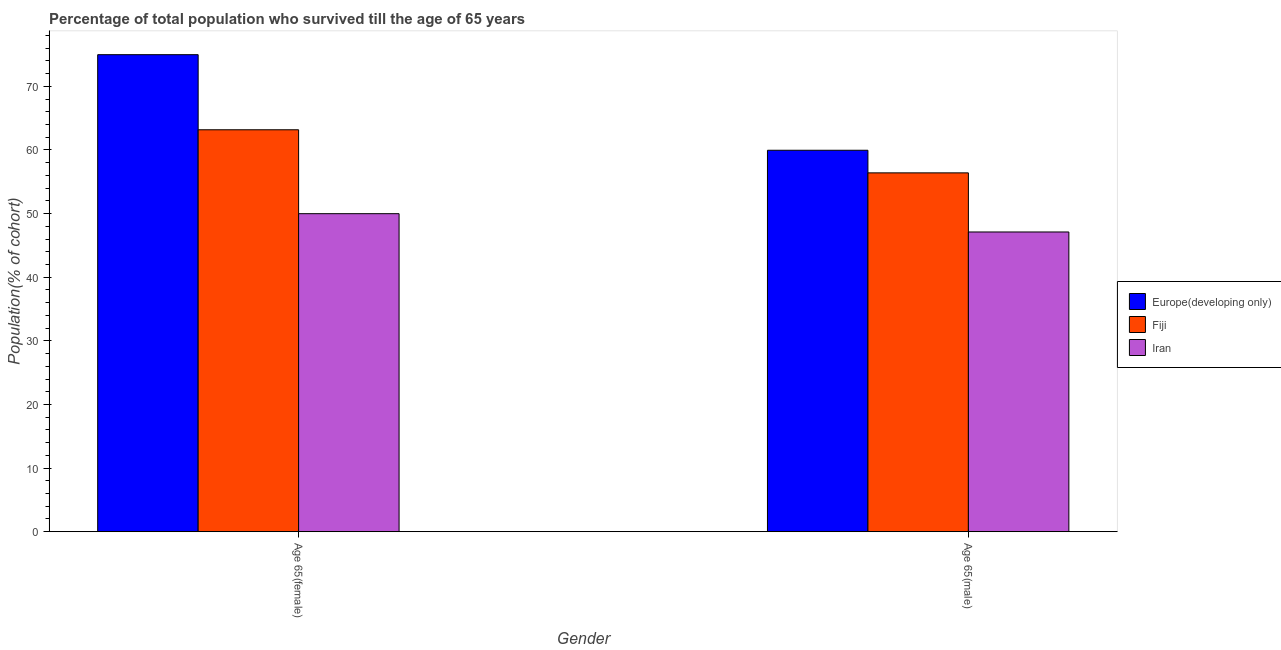How many groups of bars are there?
Provide a succinct answer. 2. Are the number of bars per tick equal to the number of legend labels?
Your answer should be compact. Yes. Are the number of bars on each tick of the X-axis equal?
Provide a short and direct response. Yes. How many bars are there on the 2nd tick from the right?
Your answer should be compact. 3. What is the label of the 1st group of bars from the left?
Your answer should be compact. Age 65(female). What is the percentage of female population who survived till age of 65 in Fiji?
Your response must be concise. 63.18. Across all countries, what is the maximum percentage of male population who survived till age of 65?
Keep it short and to the point. 59.96. Across all countries, what is the minimum percentage of female population who survived till age of 65?
Provide a short and direct response. 49.99. In which country was the percentage of male population who survived till age of 65 maximum?
Provide a short and direct response. Europe(developing only). In which country was the percentage of female population who survived till age of 65 minimum?
Your response must be concise. Iran. What is the total percentage of male population who survived till age of 65 in the graph?
Your answer should be compact. 163.47. What is the difference between the percentage of female population who survived till age of 65 in Fiji and that in Europe(developing only)?
Provide a short and direct response. -11.8. What is the difference between the percentage of male population who survived till age of 65 in Iran and the percentage of female population who survived till age of 65 in Fiji?
Provide a succinct answer. -16.06. What is the average percentage of female population who survived till age of 65 per country?
Give a very brief answer. 62.72. What is the difference between the percentage of female population who survived till age of 65 and percentage of male population who survived till age of 65 in Iran?
Your answer should be compact. 2.88. What is the ratio of the percentage of female population who survived till age of 65 in Europe(developing only) to that in Fiji?
Give a very brief answer. 1.19. Is the percentage of male population who survived till age of 65 in Iran less than that in Europe(developing only)?
Your answer should be very brief. Yes. In how many countries, is the percentage of female population who survived till age of 65 greater than the average percentage of female population who survived till age of 65 taken over all countries?
Give a very brief answer. 2. What does the 3rd bar from the left in Age 65(female) represents?
Offer a terse response. Iran. What does the 2nd bar from the right in Age 65(male) represents?
Provide a succinct answer. Fiji. Are all the bars in the graph horizontal?
Ensure brevity in your answer.  No. How many countries are there in the graph?
Provide a succinct answer. 3. Are the values on the major ticks of Y-axis written in scientific E-notation?
Your answer should be compact. No. Where does the legend appear in the graph?
Offer a terse response. Center right. How many legend labels are there?
Offer a very short reply. 3. What is the title of the graph?
Ensure brevity in your answer.  Percentage of total population who survived till the age of 65 years. Does "High income: nonOECD" appear as one of the legend labels in the graph?
Provide a short and direct response. No. What is the label or title of the X-axis?
Offer a very short reply. Gender. What is the label or title of the Y-axis?
Your response must be concise. Population(% of cohort). What is the Population(% of cohort) in Europe(developing only) in Age 65(female)?
Offer a very short reply. 74.98. What is the Population(% of cohort) of Fiji in Age 65(female)?
Your response must be concise. 63.18. What is the Population(% of cohort) in Iran in Age 65(female)?
Give a very brief answer. 49.99. What is the Population(% of cohort) in Europe(developing only) in Age 65(male)?
Keep it short and to the point. 59.96. What is the Population(% of cohort) of Fiji in Age 65(male)?
Make the answer very short. 56.4. What is the Population(% of cohort) of Iran in Age 65(male)?
Your answer should be very brief. 47.11. Across all Gender, what is the maximum Population(% of cohort) in Europe(developing only)?
Ensure brevity in your answer.  74.98. Across all Gender, what is the maximum Population(% of cohort) in Fiji?
Keep it short and to the point. 63.18. Across all Gender, what is the maximum Population(% of cohort) of Iran?
Offer a terse response. 49.99. Across all Gender, what is the minimum Population(% of cohort) of Europe(developing only)?
Offer a very short reply. 59.96. Across all Gender, what is the minimum Population(% of cohort) in Fiji?
Your answer should be compact. 56.4. Across all Gender, what is the minimum Population(% of cohort) in Iran?
Your answer should be compact. 47.11. What is the total Population(% of cohort) in Europe(developing only) in the graph?
Ensure brevity in your answer.  134.94. What is the total Population(% of cohort) in Fiji in the graph?
Make the answer very short. 119.58. What is the total Population(% of cohort) of Iran in the graph?
Your answer should be very brief. 97.1. What is the difference between the Population(% of cohort) of Europe(developing only) in Age 65(female) and that in Age 65(male)?
Offer a very short reply. 15.02. What is the difference between the Population(% of cohort) in Fiji in Age 65(female) and that in Age 65(male)?
Give a very brief answer. 6.77. What is the difference between the Population(% of cohort) in Iran in Age 65(female) and that in Age 65(male)?
Ensure brevity in your answer.  2.88. What is the difference between the Population(% of cohort) of Europe(developing only) in Age 65(female) and the Population(% of cohort) of Fiji in Age 65(male)?
Give a very brief answer. 18.58. What is the difference between the Population(% of cohort) in Europe(developing only) in Age 65(female) and the Population(% of cohort) in Iran in Age 65(male)?
Offer a very short reply. 27.87. What is the difference between the Population(% of cohort) of Fiji in Age 65(female) and the Population(% of cohort) of Iran in Age 65(male)?
Offer a terse response. 16.06. What is the average Population(% of cohort) in Europe(developing only) per Gender?
Make the answer very short. 67.47. What is the average Population(% of cohort) in Fiji per Gender?
Make the answer very short. 59.79. What is the average Population(% of cohort) in Iran per Gender?
Provide a succinct answer. 48.55. What is the difference between the Population(% of cohort) of Europe(developing only) and Population(% of cohort) of Fiji in Age 65(female)?
Offer a very short reply. 11.8. What is the difference between the Population(% of cohort) of Europe(developing only) and Population(% of cohort) of Iran in Age 65(female)?
Your answer should be very brief. 24.99. What is the difference between the Population(% of cohort) of Fiji and Population(% of cohort) of Iran in Age 65(female)?
Your answer should be compact. 13.19. What is the difference between the Population(% of cohort) in Europe(developing only) and Population(% of cohort) in Fiji in Age 65(male)?
Offer a terse response. 3.55. What is the difference between the Population(% of cohort) in Europe(developing only) and Population(% of cohort) in Iran in Age 65(male)?
Offer a very short reply. 12.84. What is the difference between the Population(% of cohort) of Fiji and Population(% of cohort) of Iran in Age 65(male)?
Offer a very short reply. 9.29. What is the ratio of the Population(% of cohort) in Europe(developing only) in Age 65(female) to that in Age 65(male)?
Keep it short and to the point. 1.25. What is the ratio of the Population(% of cohort) in Fiji in Age 65(female) to that in Age 65(male)?
Your response must be concise. 1.12. What is the ratio of the Population(% of cohort) in Iran in Age 65(female) to that in Age 65(male)?
Provide a short and direct response. 1.06. What is the difference between the highest and the second highest Population(% of cohort) of Europe(developing only)?
Provide a succinct answer. 15.02. What is the difference between the highest and the second highest Population(% of cohort) of Fiji?
Provide a short and direct response. 6.77. What is the difference between the highest and the second highest Population(% of cohort) of Iran?
Your answer should be compact. 2.88. What is the difference between the highest and the lowest Population(% of cohort) of Europe(developing only)?
Give a very brief answer. 15.02. What is the difference between the highest and the lowest Population(% of cohort) in Fiji?
Ensure brevity in your answer.  6.77. What is the difference between the highest and the lowest Population(% of cohort) of Iran?
Make the answer very short. 2.88. 